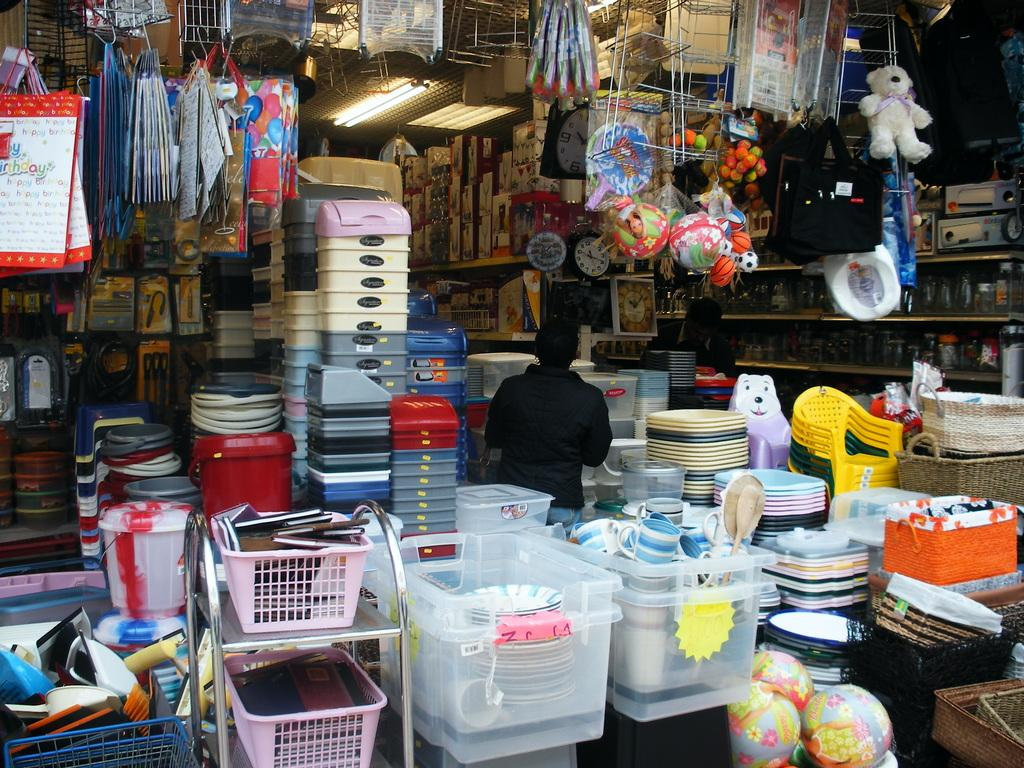<image>
Create a compact narrative representing the image presented. A collection of bins sit on a table with a bag that says "Happy Birthday" in the left corner. 